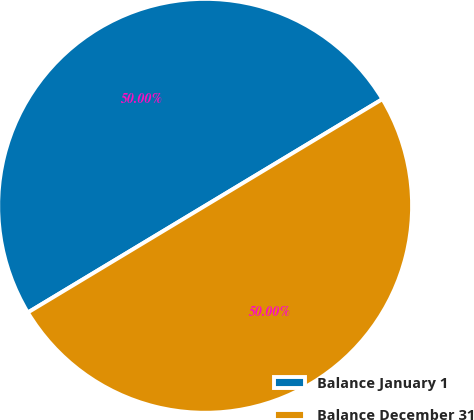Convert chart. <chart><loc_0><loc_0><loc_500><loc_500><pie_chart><fcel>Balance January 1<fcel>Balance December 31<nl><fcel>50.0%<fcel>50.0%<nl></chart> 